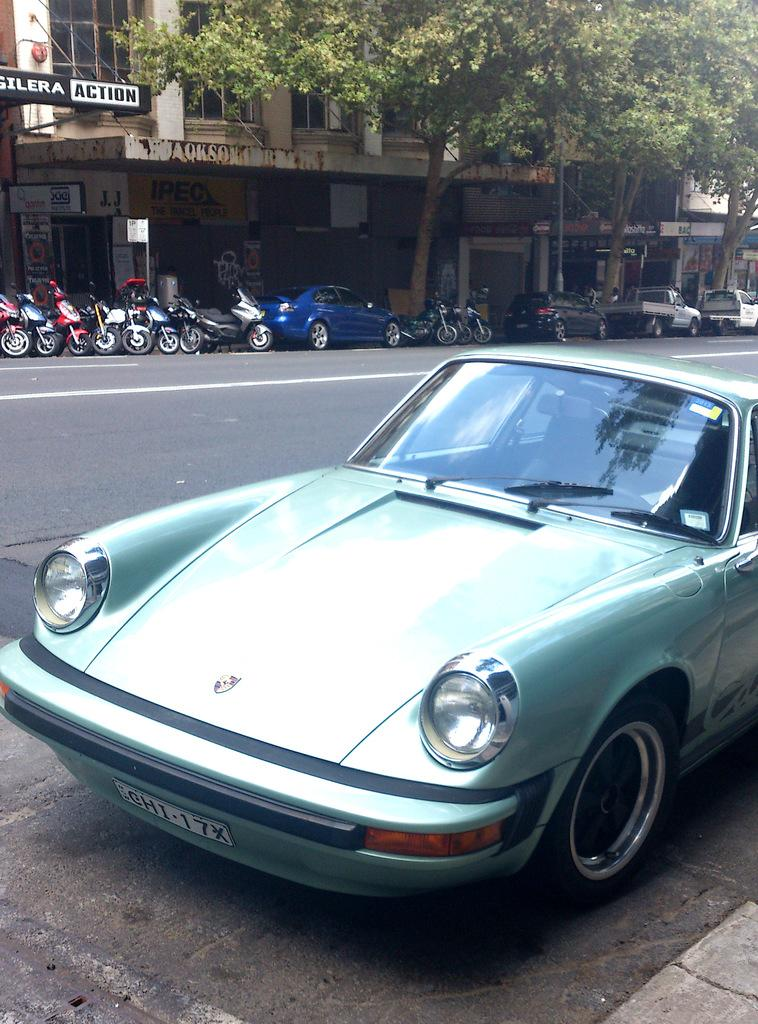What is the main subject of the image? There is a vehicle on the road in the image. What is located behind the vehicle? There are motorcycles behind the vehicle. Are there any other vehicles visible in the image? Yes, there are other vehicles visible in the image. What can be seen in the background of the image? There are poles, trees, and buildings in the background of the image. What type of fish is being offered to the driver of the vehicle in the image? There is no fish or offer present in the image; it only features vehicles on the road and objects in the background. 